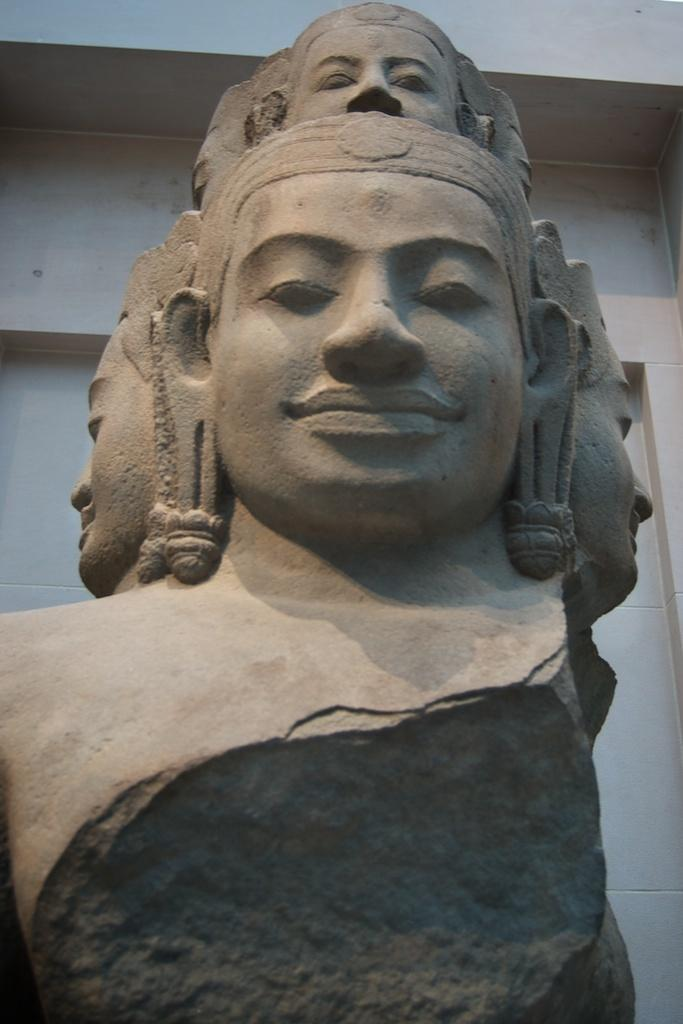What is the main subject of the image? The main subject of the image is a sculpture made up of rock. Can you describe the sculpture in more detail? Unfortunately, the image does not provide enough detail to describe the sculpture further. What can be seen in the background of the image? There is a wall visible in the background of the image. How many rabbits are hiding behind the rock sculpture in the image? There are no rabbits present in the image. What type of copy is being made of the rock sculpture in the image? There is no indication in the image that a copy is being made of the rock sculpture. 